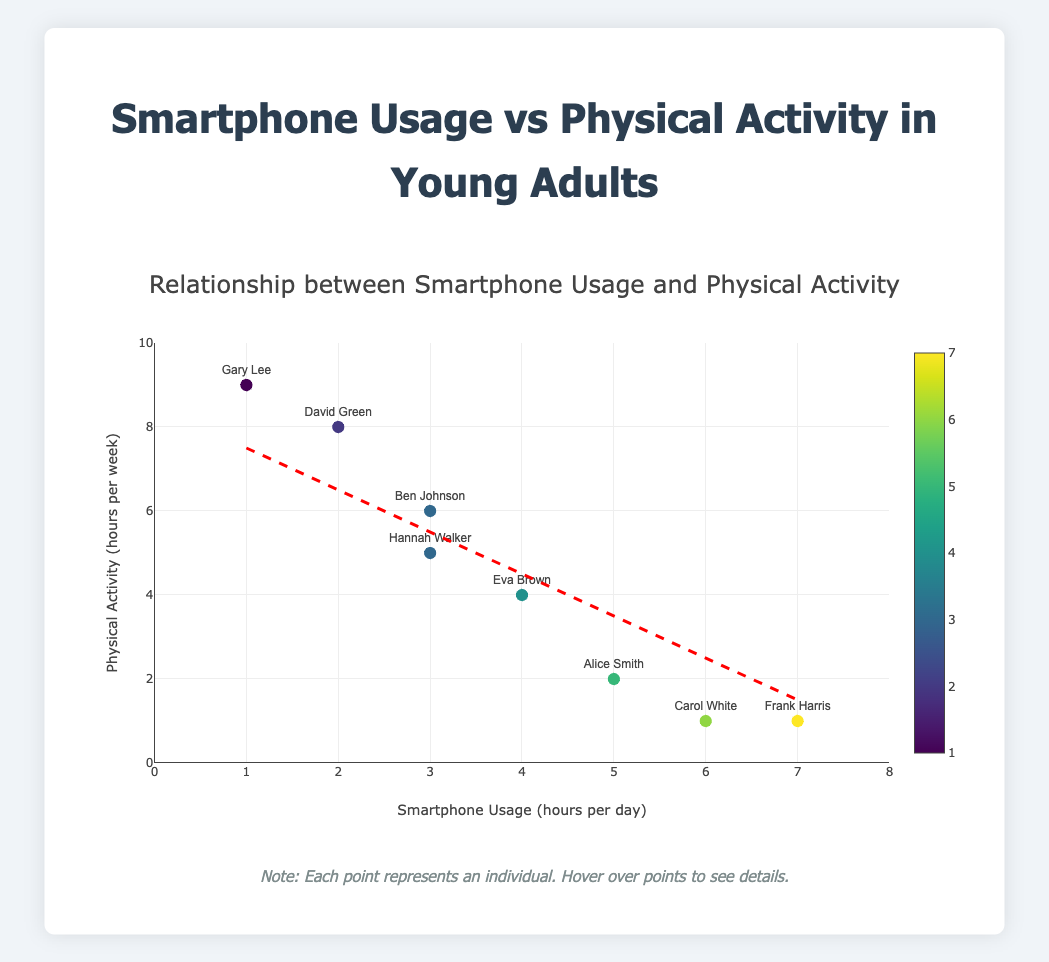What is the title of the plot? The title of the plot is positioned at the top and specifies what the plot is depicting. In this case, the title is "Relationship between Smartphone Usage and Physical Activity."
Answer: Relationship between Smartphone Usage and Physical Activity What are the x-axis and y-axis labels? The x-axis label and the y-axis label specify what each axis represents. The x-axis label is "Smartphone Usage (hours per day)" and the y-axis label is "Physical Activity (hours per week)."
Answer: Smartphone Usage (hours per day), Physical Activity (hours per week) How many data points are in the plot? Each data point represents an individual and there are a total of 8 individuals listed in the data. Therefore, there are 8 points on the graph.
Answer: 8 Which individual has the highest amount of physical activity per week? The y-axis represents physical activity, and the highest point on the axis corresponds to the individual with the most physical activity. Gary Lee is shown to have the highest physical activity at 9 hours per week.
Answer: Gary Lee Is there a visible trend between smartphone usage and physical activity? The red dashed line indicates a trend line. From the slope of the trend line, we can infer that there is a negative correlation between smartphone usage and physical activity, meaning that as smartphone usage increases, physical activity tends to decrease.
Answer: Negative correlation Who has the lowest smartphone usage and how many hours per day do they use? By observing the points on the x-axis, the individual with the lowest smartphone usage is Gary Lee, who uses it for 1 hour per day.
Answer: Gary Lee, 1 hour per day What is the average smartphone usage time per day for all individuals? Summing the smartphone usage hours for all individuals (5+3+6+2+4+7+1+3) and dividing by the number of individuals (8) gives the average. This equals (31 hours / 8 individuals) = 3.875 hours per day.
Answer: 3.875 hours per day Compare Alice Smith and Eva Brown in terms of their physical activity levels. Alice Smith has a physical activity level of 2 hours per week, while Eva Brown has a physical activity level of 4 hours per week. Therefore, Eva Brown has more physical activity than Alice Smith.
Answer: Eva Brown has more What is the maximum physical activity time recorded and who does it belong to? The highest value on the y-axis represents the maximum physical activity time, which is 9 hours per week, and this belongs to Gary Lee.
Answer: 9 hours per week, Gary Lee How does David Green's physical activity compare to Frank Harris's physical activity? David Green has a physical activity level of 8 hours per week, while Frank Harris has a physical activity level of 1 hour per week. So, David Green has significantly more physical activity than Frank Harris.
Answer: David Green has more 